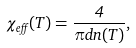Convert formula to latex. <formula><loc_0><loc_0><loc_500><loc_500>\chi _ { e f f } ( T ) = \frac { 4 } { \pi d n ( T ) } ,</formula> 